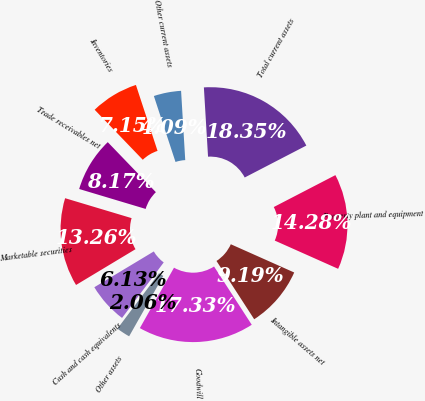Convert chart. <chart><loc_0><loc_0><loc_500><loc_500><pie_chart><fcel>Cash and cash equivalents<fcel>Marketable securities<fcel>Trade receivables net<fcel>Inventories<fcel>Other current assets<fcel>Total current assets<fcel>Property plant and equipment<fcel>Intangible assets net<fcel>Goodwill<fcel>Other assets<nl><fcel>6.13%<fcel>13.26%<fcel>8.17%<fcel>7.15%<fcel>4.09%<fcel>18.35%<fcel>14.28%<fcel>9.19%<fcel>17.33%<fcel>2.06%<nl></chart> 